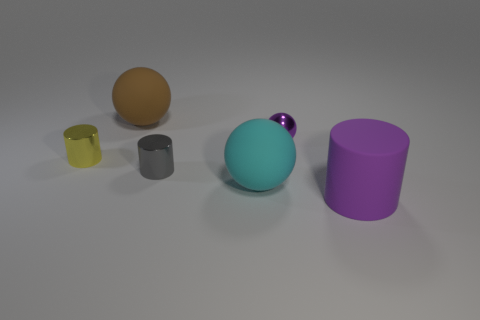Subtract all small balls. How many balls are left? 2 Add 2 tiny blue rubber things. How many objects exist? 8 Subtract all yellow cylinders. How many cylinders are left? 2 Subtract 0 blue spheres. How many objects are left? 6 Subtract 1 spheres. How many spheres are left? 2 Subtract all purple spheres. Subtract all cyan cylinders. How many spheres are left? 2 Subtract all green blocks. How many red balls are left? 0 Subtract all small brown metal objects. Subtract all tiny objects. How many objects are left? 3 Add 1 tiny objects. How many tiny objects are left? 4 Add 1 metallic cylinders. How many metallic cylinders exist? 3 